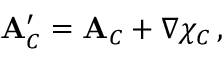Convert formula to latex. <formula><loc_0><loc_0><loc_500><loc_500>{ A } _ { C } ^ { \prime } = { A } _ { C } + \nabla \chi _ { C } \, ,</formula> 